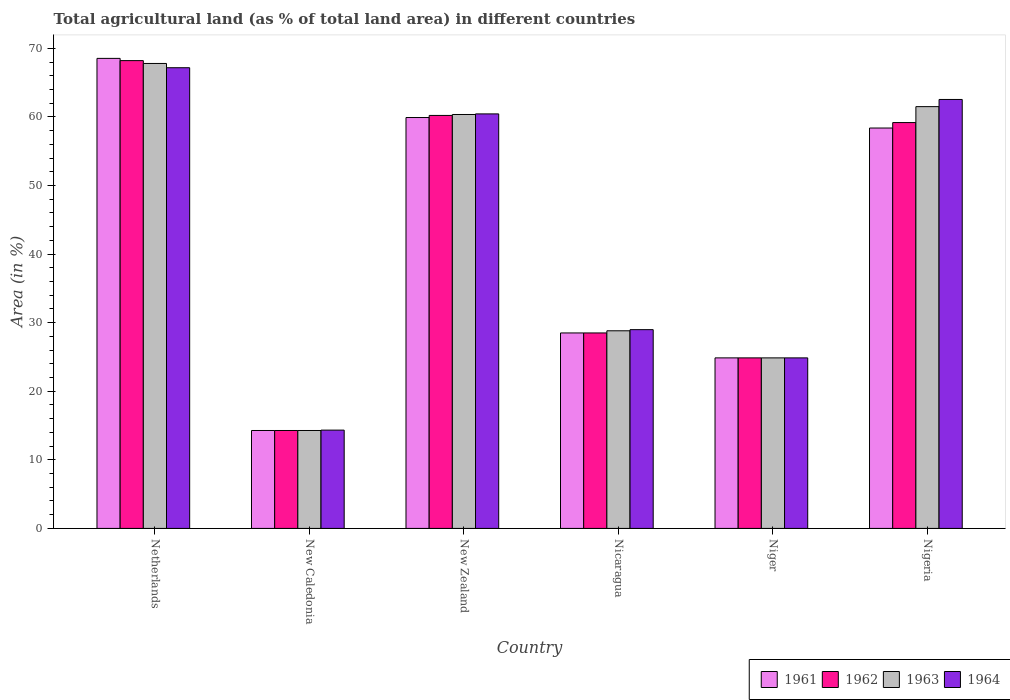How many groups of bars are there?
Ensure brevity in your answer.  6. How many bars are there on the 2nd tick from the left?
Your answer should be compact. 4. What is the label of the 2nd group of bars from the left?
Make the answer very short. New Caledonia. What is the percentage of agricultural land in 1963 in Nicaragua?
Give a very brief answer. 28.82. Across all countries, what is the maximum percentage of agricultural land in 1963?
Offer a very short reply. 67.8. Across all countries, what is the minimum percentage of agricultural land in 1962?
Keep it short and to the point. 14.28. In which country was the percentage of agricultural land in 1963 minimum?
Provide a succinct answer. New Caledonia. What is the total percentage of agricultural land in 1964 in the graph?
Offer a terse response. 258.36. What is the difference between the percentage of agricultural land in 1964 in Niger and that in Nigeria?
Your response must be concise. -37.68. What is the difference between the percentage of agricultural land in 1963 in Nigeria and the percentage of agricultural land in 1962 in Nicaragua?
Give a very brief answer. 33. What is the average percentage of agricultural land in 1961 per country?
Your answer should be compact. 42.42. What is the difference between the percentage of agricultural land of/in 1962 and percentage of agricultural land of/in 1963 in Nicaragua?
Offer a terse response. -0.32. What is the ratio of the percentage of agricultural land in 1961 in Nicaragua to that in Niger?
Offer a terse response. 1.15. Is the difference between the percentage of agricultural land in 1962 in New Zealand and Nigeria greater than the difference between the percentage of agricultural land in 1963 in New Zealand and Nigeria?
Provide a short and direct response. Yes. What is the difference between the highest and the second highest percentage of agricultural land in 1964?
Make the answer very short. 6.73. What is the difference between the highest and the lowest percentage of agricultural land in 1961?
Your answer should be compact. 54.26. In how many countries, is the percentage of agricultural land in 1961 greater than the average percentage of agricultural land in 1961 taken over all countries?
Your answer should be compact. 3. Is the sum of the percentage of agricultural land in 1963 in New Zealand and Niger greater than the maximum percentage of agricultural land in 1964 across all countries?
Ensure brevity in your answer.  Yes. What does the 4th bar from the left in Nigeria represents?
Make the answer very short. 1964. What does the 1st bar from the right in Niger represents?
Your answer should be compact. 1964. Is it the case that in every country, the sum of the percentage of agricultural land in 1962 and percentage of agricultural land in 1963 is greater than the percentage of agricultural land in 1961?
Your response must be concise. Yes. Are all the bars in the graph horizontal?
Give a very brief answer. No. How many countries are there in the graph?
Keep it short and to the point. 6. What is the difference between two consecutive major ticks on the Y-axis?
Ensure brevity in your answer.  10. Are the values on the major ticks of Y-axis written in scientific E-notation?
Offer a terse response. No. Does the graph contain any zero values?
Offer a terse response. No. Does the graph contain grids?
Offer a very short reply. No. Where does the legend appear in the graph?
Your response must be concise. Bottom right. How many legend labels are there?
Your answer should be very brief. 4. What is the title of the graph?
Your answer should be compact. Total agricultural land (as % of total land area) in different countries. What is the label or title of the X-axis?
Your answer should be very brief. Country. What is the label or title of the Y-axis?
Give a very brief answer. Area (in %). What is the Area (in %) of 1961 in Netherlands?
Your answer should be compact. 68.54. What is the Area (in %) of 1962 in Netherlands?
Make the answer very short. 68.22. What is the Area (in %) of 1963 in Netherlands?
Your response must be concise. 67.8. What is the Area (in %) in 1964 in Netherlands?
Keep it short and to the point. 67.18. What is the Area (in %) in 1961 in New Caledonia?
Offer a very short reply. 14.28. What is the Area (in %) of 1962 in New Caledonia?
Give a very brief answer. 14.28. What is the Area (in %) of 1963 in New Caledonia?
Provide a short and direct response. 14.28. What is the Area (in %) of 1964 in New Caledonia?
Keep it short and to the point. 14.33. What is the Area (in %) in 1961 in New Zealand?
Your answer should be very brief. 59.92. What is the Area (in %) of 1962 in New Zealand?
Provide a succinct answer. 60.22. What is the Area (in %) in 1963 in New Zealand?
Give a very brief answer. 60.36. What is the Area (in %) of 1964 in New Zealand?
Your answer should be compact. 60.45. What is the Area (in %) in 1961 in Nicaragua?
Offer a terse response. 28.5. What is the Area (in %) in 1962 in Nicaragua?
Give a very brief answer. 28.5. What is the Area (in %) in 1963 in Nicaragua?
Your answer should be very brief. 28.82. What is the Area (in %) in 1964 in Nicaragua?
Provide a succinct answer. 28.98. What is the Area (in %) in 1961 in Niger?
Keep it short and to the point. 24.87. What is the Area (in %) of 1962 in Niger?
Your answer should be compact. 24.87. What is the Area (in %) of 1963 in Niger?
Provide a succinct answer. 24.87. What is the Area (in %) in 1964 in Niger?
Give a very brief answer. 24.87. What is the Area (in %) of 1961 in Nigeria?
Ensure brevity in your answer.  58.39. What is the Area (in %) in 1962 in Nigeria?
Your response must be concise. 59.18. What is the Area (in %) of 1963 in Nigeria?
Offer a terse response. 61.51. What is the Area (in %) in 1964 in Nigeria?
Keep it short and to the point. 62.55. Across all countries, what is the maximum Area (in %) in 1961?
Your answer should be very brief. 68.54. Across all countries, what is the maximum Area (in %) of 1962?
Make the answer very short. 68.22. Across all countries, what is the maximum Area (in %) in 1963?
Your answer should be very brief. 67.8. Across all countries, what is the maximum Area (in %) in 1964?
Give a very brief answer. 67.18. Across all countries, what is the minimum Area (in %) in 1961?
Provide a succinct answer. 14.28. Across all countries, what is the minimum Area (in %) in 1962?
Give a very brief answer. 14.28. Across all countries, what is the minimum Area (in %) in 1963?
Offer a very short reply. 14.28. Across all countries, what is the minimum Area (in %) in 1964?
Offer a terse response. 14.33. What is the total Area (in %) in 1961 in the graph?
Offer a very short reply. 254.5. What is the total Area (in %) of 1962 in the graph?
Provide a short and direct response. 255.27. What is the total Area (in %) of 1963 in the graph?
Provide a short and direct response. 257.63. What is the total Area (in %) in 1964 in the graph?
Give a very brief answer. 258.36. What is the difference between the Area (in %) of 1961 in Netherlands and that in New Caledonia?
Your response must be concise. 54.26. What is the difference between the Area (in %) of 1962 in Netherlands and that in New Caledonia?
Your answer should be very brief. 53.94. What is the difference between the Area (in %) in 1963 in Netherlands and that in New Caledonia?
Keep it short and to the point. 53.52. What is the difference between the Area (in %) of 1964 in Netherlands and that in New Caledonia?
Your response must be concise. 52.85. What is the difference between the Area (in %) in 1961 in Netherlands and that in New Zealand?
Provide a short and direct response. 8.62. What is the difference between the Area (in %) in 1962 in Netherlands and that in New Zealand?
Offer a very short reply. 8. What is the difference between the Area (in %) in 1963 in Netherlands and that in New Zealand?
Your response must be concise. 7.44. What is the difference between the Area (in %) of 1964 in Netherlands and that in New Zealand?
Offer a terse response. 6.73. What is the difference between the Area (in %) in 1961 in Netherlands and that in Nicaragua?
Offer a very short reply. 40.04. What is the difference between the Area (in %) in 1962 in Netherlands and that in Nicaragua?
Make the answer very short. 39.71. What is the difference between the Area (in %) of 1963 in Netherlands and that in Nicaragua?
Your response must be concise. 38.98. What is the difference between the Area (in %) of 1964 in Netherlands and that in Nicaragua?
Offer a terse response. 38.2. What is the difference between the Area (in %) of 1961 in Netherlands and that in Niger?
Make the answer very short. 43.67. What is the difference between the Area (in %) of 1962 in Netherlands and that in Niger?
Your answer should be very brief. 43.35. What is the difference between the Area (in %) of 1963 in Netherlands and that in Niger?
Offer a very short reply. 42.93. What is the difference between the Area (in %) in 1964 in Netherlands and that in Niger?
Provide a succinct answer. 42.31. What is the difference between the Area (in %) in 1961 in Netherlands and that in Nigeria?
Keep it short and to the point. 10.16. What is the difference between the Area (in %) in 1962 in Netherlands and that in Nigeria?
Provide a succinct answer. 9.04. What is the difference between the Area (in %) of 1963 in Netherlands and that in Nigeria?
Make the answer very short. 6.3. What is the difference between the Area (in %) in 1964 in Netherlands and that in Nigeria?
Keep it short and to the point. 4.63. What is the difference between the Area (in %) in 1961 in New Caledonia and that in New Zealand?
Your response must be concise. -45.64. What is the difference between the Area (in %) in 1962 in New Caledonia and that in New Zealand?
Provide a succinct answer. -45.94. What is the difference between the Area (in %) of 1963 in New Caledonia and that in New Zealand?
Keep it short and to the point. -46.08. What is the difference between the Area (in %) of 1964 in New Caledonia and that in New Zealand?
Your answer should be compact. -46.11. What is the difference between the Area (in %) of 1961 in New Caledonia and that in Nicaragua?
Make the answer very short. -14.22. What is the difference between the Area (in %) in 1962 in New Caledonia and that in Nicaragua?
Provide a succinct answer. -14.22. What is the difference between the Area (in %) in 1963 in New Caledonia and that in Nicaragua?
Keep it short and to the point. -14.54. What is the difference between the Area (in %) of 1964 in New Caledonia and that in Nicaragua?
Provide a succinct answer. -14.65. What is the difference between the Area (in %) in 1961 in New Caledonia and that in Niger?
Your response must be concise. -10.59. What is the difference between the Area (in %) of 1962 in New Caledonia and that in Niger?
Offer a terse response. -10.59. What is the difference between the Area (in %) in 1963 in New Caledonia and that in Niger?
Your answer should be very brief. -10.59. What is the difference between the Area (in %) of 1964 in New Caledonia and that in Niger?
Keep it short and to the point. -10.54. What is the difference between the Area (in %) in 1961 in New Caledonia and that in Nigeria?
Offer a terse response. -44.11. What is the difference between the Area (in %) in 1962 in New Caledonia and that in Nigeria?
Your answer should be compact. -44.9. What is the difference between the Area (in %) in 1963 in New Caledonia and that in Nigeria?
Give a very brief answer. -47.23. What is the difference between the Area (in %) of 1964 in New Caledonia and that in Nigeria?
Offer a terse response. -48.22. What is the difference between the Area (in %) in 1961 in New Zealand and that in Nicaragua?
Give a very brief answer. 31.42. What is the difference between the Area (in %) in 1962 in New Zealand and that in Nicaragua?
Offer a very short reply. 31.72. What is the difference between the Area (in %) of 1963 in New Zealand and that in Nicaragua?
Ensure brevity in your answer.  31.54. What is the difference between the Area (in %) in 1964 in New Zealand and that in Nicaragua?
Your response must be concise. 31.46. What is the difference between the Area (in %) in 1961 in New Zealand and that in Niger?
Offer a terse response. 35.05. What is the difference between the Area (in %) of 1962 in New Zealand and that in Niger?
Offer a terse response. 35.35. What is the difference between the Area (in %) in 1963 in New Zealand and that in Niger?
Offer a very short reply. 35.49. What is the difference between the Area (in %) of 1964 in New Zealand and that in Niger?
Your answer should be compact. 35.58. What is the difference between the Area (in %) of 1961 in New Zealand and that in Nigeria?
Ensure brevity in your answer.  1.53. What is the difference between the Area (in %) in 1962 in New Zealand and that in Nigeria?
Your answer should be very brief. 1.04. What is the difference between the Area (in %) of 1963 in New Zealand and that in Nigeria?
Provide a succinct answer. -1.15. What is the difference between the Area (in %) of 1964 in New Zealand and that in Nigeria?
Provide a short and direct response. -2.11. What is the difference between the Area (in %) in 1961 in Nicaragua and that in Niger?
Provide a succinct answer. 3.63. What is the difference between the Area (in %) in 1962 in Nicaragua and that in Niger?
Provide a succinct answer. 3.63. What is the difference between the Area (in %) in 1963 in Nicaragua and that in Niger?
Your answer should be compact. 3.95. What is the difference between the Area (in %) in 1964 in Nicaragua and that in Niger?
Your answer should be very brief. 4.12. What is the difference between the Area (in %) of 1961 in Nicaragua and that in Nigeria?
Keep it short and to the point. -29.88. What is the difference between the Area (in %) in 1962 in Nicaragua and that in Nigeria?
Your response must be concise. -30.68. What is the difference between the Area (in %) of 1963 in Nicaragua and that in Nigeria?
Your answer should be compact. -32.69. What is the difference between the Area (in %) of 1964 in Nicaragua and that in Nigeria?
Offer a terse response. -33.57. What is the difference between the Area (in %) of 1961 in Niger and that in Nigeria?
Your answer should be very brief. -33.52. What is the difference between the Area (in %) of 1962 in Niger and that in Nigeria?
Give a very brief answer. -34.31. What is the difference between the Area (in %) in 1963 in Niger and that in Nigeria?
Provide a succinct answer. -36.64. What is the difference between the Area (in %) of 1964 in Niger and that in Nigeria?
Make the answer very short. -37.68. What is the difference between the Area (in %) of 1961 in Netherlands and the Area (in %) of 1962 in New Caledonia?
Offer a terse response. 54.26. What is the difference between the Area (in %) in 1961 in Netherlands and the Area (in %) in 1963 in New Caledonia?
Ensure brevity in your answer.  54.26. What is the difference between the Area (in %) of 1961 in Netherlands and the Area (in %) of 1964 in New Caledonia?
Your response must be concise. 54.21. What is the difference between the Area (in %) in 1962 in Netherlands and the Area (in %) in 1963 in New Caledonia?
Offer a terse response. 53.94. What is the difference between the Area (in %) of 1962 in Netherlands and the Area (in %) of 1964 in New Caledonia?
Make the answer very short. 53.88. What is the difference between the Area (in %) of 1963 in Netherlands and the Area (in %) of 1964 in New Caledonia?
Offer a terse response. 53.47. What is the difference between the Area (in %) in 1961 in Netherlands and the Area (in %) in 1962 in New Zealand?
Provide a succinct answer. 8.32. What is the difference between the Area (in %) of 1961 in Netherlands and the Area (in %) of 1963 in New Zealand?
Offer a terse response. 8.18. What is the difference between the Area (in %) in 1961 in Netherlands and the Area (in %) in 1964 in New Zealand?
Provide a short and direct response. 8.1. What is the difference between the Area (in %) in 1962 in Netherlands and the Area (in %) in 1963 in New Zealand?
Make the answer very short. 7.86. What is the difference between the Area (in %) of 1962 in Netherlands and the Area (in %) of 1964 in New Zealand?
Offer a very short reply. 7.77. What is the difference between the Area (in %) of 1963 in Netherlands and the Area (in %) of 1964 in New Zealand?
Your answer should be very brief. 7.36. What is the difference between the Area (in %) in 1961 in Netherlands and the Area (in %) in 1962 in Nicaragua?
Provide a short and direct response. 40.04. What is the difference between the Area (in %) of 1961 in Netherlands and the Area (in %) of 1963 in Nicaragua?
Offer a terse response. 39.72. What is the difference between the Area (in %) in 1961 in Netherlands and the Area (in %) in 1964 in Nicaragua?
Provide a succinct answer. 39.56. What is the difference between the Area (in %) in 1962 in Netherlands and the Area (in %) in 1963 in Nicaragua?
Your answer should be very brief. 39.4. What is the difference between the Area (in %) in 1962 in Netherlands and the Area (in %) in 1964 in Nicaragua?
Keep it short and to the point. 39.23. What is the difference between the Area (in %) in 1963 in Netherlands and the Area (in %) in 1964 in Nicaragua?
Provide a succinct answer. 38.82. What is the difference between the Area (in %) of 1961 in Netherlands and the Area (in %) of 1962 in Niger?
Give a very brief answer. 43.67. What is the difference between the Area (in %) in 1961 in Netherlands and the Area (in %) in 1963 in Niger?
Give a very brief answer. 43.67. What is the difference between the Area (in %) in 1961 in Netherlands and the Area (in %) in 1964 in Niger?
Keep it short and to the point. 43.67. What is the difference between the Area (in %) in 1962 in Netherlands and the Area (in %) in 1963 in Niger?
Provide a succinct answer. 43.35. What is the difference between the Area (in %) of 1962 in Netherlands and the Area (in %) of 1964 in Niger?
Provide a succinct answer. 43.35. What is the difference between the Area (in %) in 1963 in Netherlands and the Area (in %) in 1964 in Niger?
Your answer should be compact. 42.93. What is the difference between the Area (in %) in 1961 in Netherlands and the Area (in %) in 1962 in Nigeria?
Offer a terse response. 9.36. What is the difference between the Area (in %) of 1961 in Netherlands and the Area (in %) of 1963 in Nigeria?
Offer a very short reply. 7.04. What is the difference between the Area (in %) in 1961 in Netherlands and the Area (in %) in 1964 in Nigeria?
Your answer should be very brief. 5.99. What is the difference between the Area (in %) of 1962 in Netherlands and the Area (in %) of 1963 in Nigeria?
Offer a terse response. 6.71. What is the difference between the Area (in %) of 1962 in Netherlands and the Area (in %) of 1964 in Nigeria?
Offer a terse response. 5.66. What is the difference between the Area (in %) in 1963 in Netherlands and the Area (in %) in 1964 in Nigeria?
Provide a short and direct response. 5.25. What is the difference between the Area (in %) in 1961 in New Caledonia and the Area (in %) in 1962 in New Zealand?
Keep it short and to the point. -45.94. What is the difference between the Area (in %) of 1961 in New Caledonia and the Area (in %) of 1963 in New Zealand?
Your answer should be very brief. -46.08. What is the difference between the Area (in %) in 1961 in New Caledonia and the Area (in %) in 1964 in New Zealand?
Offer a very short reply. -46.17. What is the difference between the Area (in %) in 1962 in New Caledonia and the Area (in %) in 1963 in New Zealand?
Provide a succinct answer. -46.08. What is the difference between the Area (in %) in 1962 in New Caledonia and the Area (in %) in 1964 in New Zealand?
Make the answer very short. -46.17. What is the difference between the Area (in %) in 1963 in New Caledonia and the Area (in %) in 1964 in New Zealand?
Ensure brevity in your answer.  -46.17. What is the difference between the Area (in %) of 1961 in New Caledonia and the Area (in %) of 1962 in Nicaragua?
Keep it short and to the point. -14.22. What is the difference between the Area (in %) in 1961 in New Caledonia and the Area (in %) in 1963 in Nicaragua?
Give a very brief answer. -14.54. What is the difference between the Area (in %) in 1961 in New Caledonia and the Area (in %) in 1964 in Nicaragua?
Ensure brevity in your answer.  -14.71. What is the difference between the Area (in %) of 1962 in New Caledonia and the Area (in %) of 1963 in Nicaragua?
Your response must be concise. -14.54. What is the difference between the Area (in %) in 1962 in New Caledonia and the Area (in %) in 1964 in Nicaragua?
Your answer should be compact. -14.71. What is the difference between the Area (in %) of 1963 in New Caledonia and the Area (in %) of 1964 in Nicaragua?
Your answer should be compact. -14.71. What is the difference between the Area (in %) in 1961 in New Caledonia and the Area (in %) in 1962 in Niger?
Ensure brevity in your answer.  -10.59. What is the difference between the Area (in %) in 1961 in New Caledonia and the Area (in %) in 1963 in Niger?
Your answer should be very brief. -10.59. What is the difference between the Area (in %) in 1961 in New Caledonia and the Area (in %) in 1964 in Niger?
Make the answer very short. -10.59. What is the difference between the Area (in %) in 1962 in New Caledonia and the Area (in %) in 1963 in Niger?
Your response must be concise. -10.59. What is the difference between the Area (in %) in 1962 in New Caledonia and the Area (in %) in 1964 in Niger?
Provide a short and direct response. -10.59. What is the difference between the Area (in %) of 1963 in New Caledonia and the Area (in %) of 1964 in Niger?
Offer a terse response. -10.59. What is the difference between the Area (in %) in 1961 in New Caledonia and the Area (in %) in 1962 in Nigeria?
Give a very brief answer. -44.9. What is the difference between the Area (in %) of 1961 in New Caledonia and the Area (in %) of 1963 in Nigeria?
Offer a very short reply. -47.23. What is the difference between the Area (in %) in 1961 in New Caledonia and the Area (in %) in 1964 in Nigeria?
Give a very brief answer. -48.27. What is the difference between the Area (in %) in 1962 in New Caledonia and the Area (in %) in 1963 in Nigeria?
Offer a very short reply. -47.23. What is the difference between the Area (in %) in 1962 in New Caledonia and the Area (in %) in 1964 in Nigeria?
Keep it short and to the point. -48.27. What is the difference between the Area (in %) in 1963 in New Caledonia and the Area (in %) in 1964 in Nigeria?
Your response must be concise. -48.27. What is the difference between the Area (in %) in 1961 in New Zealand and the Area (in %) in 1962 in Nicaragua?
Keep it short and to the point. 31.42. What is the difference between the Area (in %) of 1961 in New Zealand and the Area (in %) of 1963 in Nicaragua?
Provide a short and direct response. 31.1. What is the difference between the Area (in %) in 1961 in New Zealand and the Area (in %) in 1964 in Nicaragua?
Give a very brief answer. 30.93. What is the difference between the Area (in %) in 1962 in New Zealand and the Area (in %) in 1963 in Nicaragua?
Your answer should be very brief. 31.4. What is the difference between the Area (in %) in 1962 in New Zealand and the Area (in %) in 1964 in Nicaragua?
Give a very brief answer. 31.24. What is the difference between the Area (in %) in 1963 in New Zealand and the Area (in %) in 1964 in Nicaragua?
Provide a short and direct response. 31.37. What is the difference between the Area (in %) of 1961 in New Zealand and the Area (in %) of 1962 in Niger?
Give a very brief answer. 35.05. What is the difference between the Area (in %) in 1961 in New Zealand and the Area (in %) in 1963 in Niger?
Provide a succinct answer. 35.05. What is the difference between the Area (in %) of 1961 in New Zealand and the Area (in %) of 1964 in Niger?
Ensure brevity in your answer.  35.05. What is the difference between the Area (in %) of 1962 in New Zealand and the Area (in %) of 1963 in Niger?
Give a very brief answer. 35.35. What is the difference between the Area (in %) of 1962 in New Zealand and the Area (in %) of 1964 in Niger?
Your answer should be compact. 35.35. What is the difference between the Area (in %) of 1963 in New Zealand and the Area (in %) of 1964 in Niger?
Give a very brief answer. 35.49. What is the difference between the Area (in %) of 1961 in New Zealand and the Area (in %) of 1962 in Nigeria?
Make the answer very short. 0.74. What is the difference between the Area (in %) of 1961 in New Zealand and the Area (in %) of 1963 in Nigeria?
Offer a terse response. -1.59. What is the difference between the Area (in %) of 1961 in New Zealand and the Area (in %) of 1964 in Nigeria?
Make the answer very short. -2.63. What is the difference between the Area (in %) of 1962 in New Zealand and the Area (in %) of 1963 in Nigeria?
Give a very brief answer. -1.28. What is the difference between the Area (in %) of 1962 in New Zealand and the Area (in %) of 1964 in Nigeria?
Offer a terse response. -2.33. What is the difference between the Area (in %) of 1963 in New Zealand and the Area (in %) of 1964 in Nigeria?
Offer a terse response. -2.19. What is the difference between the Area (in %) in 1961 in Nicaragua and the Area (in %) in 1962 in Niger?
Offer a very short reply. 3.63. What is the difference between the Area (in %) in 1961 in Nicaragua and the Area (in %) in 1963 in Niger?
Make the answer very short. 3.63. What is the difference between the Area (in %) in 1961 in Nicaragua and the Area (in %) in 1964 in Niger?
Your response must be concise. 3.63. What is the difference between the Area (in %) of 1962 in Nicaragua and the Area (in %) of 1963 in Niger?
Ensure brevity in your answer.  3.63. What is the difference between the Area (in %) in 1962 in Nicaragua and the Area (in %) in 1964 in Niger?
Your response must be concise. 3.63. What is the difference between the Area (in %) in 1963 in Nicaragua and the Area (in %) in 1964 in Niger?
Provide a succinct answer. 3.95. What is the difference between the Area (in %) in 1961 in Nicaragua and the Area (in %) in 1962 in Nigeria?
Make the answer very short. -30.68. What is the difference between the Area (in %) of 1961 in Nicaragua and the Area (in %) of 1963 in Nigeria?
Ensure brevity in your answer.  -33. What is the difference between the Area (in %) in 1961 in Nicaragua and the Area (in %) in 1964 in Nigeria?
Your answer should be compact. -34.05. What is the difference between the Area (in %) in 1962 in Nicaragua and the Area (in %) in 1963 in Nigeria?
Give a very brief answer. -33. What is the difference between the Area (in %) of 1962 in Nicaragua and the Area (in %) of 1964 in Nigeria?
Your answer should be very brief. -34.05. What is the difference between the Area (in %) in 1963 in Nicaragua and the Area (in %) in 1964 in Nigeria?
Provide a succinct answer. -33.73. What is the difference between the Area (in %) of 1961 in Niger and the Area (in %) of 1962 in Nigeria?
Offer a terse response. -34.31. What is the difference between the Area (in %) of 1961 in Niger and the Area (in %) of 1963 in Nigeria?
Your response must be concise. -36.64. What is the difference between the Area (in %) of 1961 in Niger and the Area (in %) of 1964 in Nigeria?
Your answer should be very brief. -37.68. What is the difference between the Area (in %) in 1962 in Niger and the Area (in %) in 1963 in Nigeria?
Make the answer very short. -36.64. What is the difference between the Area (in %) of 1962 in Niger and the Area (in %) of 1964 in Nigeria?
Offer a very short reply. -37.68. What is the difference between the Area (in %) in 1963 in Niger and the Area (in %) in 1964 in Nigeria?
Offer a terse response. -37.68. What is the average Area (in %) of 1961 per country?
Your answer should be very brief. 42.42. What is the average Area (in %) in 1962 per country?
Your response must be concise. 42.54. What is the average Area (in %) of 1963 per country?
Offer a very short reply. 42.94. What is the average Area (in %) in 1964 per country?
Make the answer very short. 43.06. What is the difference between the Area (in %) in 1961 and Area (in %) in 1962 in Netherlands?
Make the answer very short. 0.33. What is the difference between the Area (in %) in 1961 and Area (in %) in 1963 in Netherlands?
Offer a terse response. 0.74. What is the difference between the Area (in %) in 1961 and Area (in %) in 1964 in Netherlands?
Provide a succinct answer. 1.36. What is the difference between the Area (in %) in 1962 and Area (in %) in 1963 in Netherlands?
Offer a terse response. 0.41. What is the difference between the Area (in %) of 1962 and Area (in %) of 1964 in Netherlands?
Give a very brief answer. 1.04. What is the difference between the Area (in %) in 1963 and Area (in %) in 1964 in Netherlands?
Offer a very short reply. 0.62. What is the difference between the Area (in %) in 1961 and Area (in %) in 1963 in New Caledonia?
Offer a very short reply. 0. What is the difference between the Area (in %) of 1961 and Area (in %) of 1964 in New Caledonia?
Keep it short and to the point. -0.05. What is the difference between the Area (in %) in 1962 and Area (in %) in 1964 in New Caledonia?
Provide a succinct answer. -0.05. What is the difference between the Area (in %) in 1963 and Area (in %) in 1964 in New Caledonia?
Offer a very short reply. -0.05. What is the difference between the Area (in %) in 1961 and Area (in %) in 1962 in New Zealand?
Keep it short and to the point. -0.3. What is the difference between the Area (in %) in 1961 and Area (in %) in 1963 in New Zealand?
Ensure brevity in your answer.  -0.44. What is the difference between the Area (in %) of 1961 and Area (in %) of 1964 in New Zealand?
Offer a terse response. -0.53. What is the difference between the Area (in %) of 1962 and Area (in %) of 1963 in New Zealand?
Give a very brief answer. -0.14. What is the difference between the Area (in %) in 1962 and Area (in %) in 1964 in New Zealand?
Your answer should be very brief. -0.22. What is the difference between the Area (in %) in 1963 and Area (in %) in 1964 in New Zealand?
Keep it short and to the point. -0.09. What is the difference between the Area (in %) of 1961 and Area (in %) of 1963 in Nicaragua?
Your answer should be compact. -0.32. What is the difference between the Area (in %) in 1961 and Area (in %) in 1964 in Nicaragua?
Ensure brevity in your answer.  -0.48. What is the difference between the Area (in %) in 1962 and Area (in %) in 1963 in Nicaragua?
Make the answer very short. -0.32. What is the difference between the Area (in %) of 1962 and Area (in %) of 1964 in Nicaragua?
Your answer should be very brief. -0.48. What is the difference between the Area (in %) in 1963 and Area (in %) in 1964 in Nicaragua?
Offer a very short reply. -0.17. What is the difference between the Area (in %) of 1961 and Area (in %) of 1962 in Niger?
Offer a very short reply. 0. What is the difference between the Area (in %) in 1961 and Area (in %) in 1963 in Niger?
Provide a short and direct response. 0. What is the difference between the Area (in %) in 1961 and Area (in %) in 1964 in Niger?
Your answer should be very brief. 0. What is the difference between the Area (in %) of 1962 and Area (in %) of 1964 in Niger?
Your answer should be compact. 0. What is the difference between the Area (in %) in 1963 and Area (in %) in 1964 in Niger?
Your response must be concise. 0. What is the difference between the Area (in %) in 1961 and Area (in %) in 1962 in Nigeria?
Make the answer very short. -0.79. What is the difference between the Area (in %) of 1961 and Area (in %) of 1963 in Nigeria?
Offer a terse response. -3.12. What is the difference between the Area (in %) in 1961 and Area (in %) in 1964 in Nigeria?
Provide a short and direct response. -4.17. What is the difference between the Area (in %) in 1962 and Area (in %) in 1963 in Nigeria?
Ensure brevity in your answer.  -2.32. What is the difference between the Area (in %) of 1962 and Area (in %) of 1964 in Nigeria?
Offer a terse response. -3.37. What is the difference between the Area (in %) of 1963 and Area (in %) of 1964 in Nigeria?
Offer a terse response. -1.05. What is the ratio of the Area (in %) in 1961 in Netherlands to that in New Caledonia?
Offer a terse response. 4.8. What is the ratio of the Area (in %) of 1962 in Netherlands to that in New Caledonia?
Provide a short and direct response. 4.78. What is the ratio of the Area (in %) in 1963 in Netherlands to that in New Caledonia?
Your answer should be compact. 4.75. What is the ratio of the Area (in %) of 1964 in Netherlands to that in New Caledonia?
Provide a succinct answer. 4.69. What is the ratio of the Area (in %) in 1961 in Netherlands to that in New Zealand?
Your response must be concise. 1.14. What is the ratio of the Area (in %) in 1962 in Netherlands to that in New Zealand?
Keep it short and to the point. 1.13. What is the ratio of the Area (in %) of 1963 in Netherlands to that in New Zealand?
Offer a terse response. 1.12. What is the ratio of the Area (in %) of 1964 in Netherlands to that in New Zealand?
Give a very brief answer. 1.11. What is the ratio of the Area (in %) in 1961 in Netherlands to that in Nicaragua?
Your response must be concise. 2.4. What is the ratio of the Area (in %) in 1962 in Netherlands to that in Nicaragua?
Offer a very short reply. 2.39. What is the ratio of the Area (in %) of 1963 in Netherlands to that in Nicaragua?
Provide a succinct answer. 2.35. What is the ratio of the Area (in %) in 1964 in Netherlands to that in Nicaragua?
Make the answer very short. 2.32. What is the ratio of the Area (in %) in 1961 in Netherlands to that in Niger?
Provide a succinct answer. 2.76. What is the ratio of the Area (in %) of 1962 in Netherlands to that in Niger?
Your answer should be compact. 2.74. What is the ratio of the Area (in %) of 1963 in Netherlands to that in Niger?
Provide a succinct answer. 2.73. What is the ratio of the Area (in %) in 1964 in Netherlands to that in Niger?
Keep it short and to the point. 2.7. What is the ratio of the Area (in %) of 1961 in Netherlands to that in Nigeria?
Offer a very short reply. 1.17. What is the ratio of the Area (in %) in 1962 in Netherlands to that in Nigeria?
Keep it short and to the point. 1.15. What is the ratio of the Area (in %) of 1963 in Netherlands to that in Nigeria?
Your response must be concise. 1.1. What is the ratio of the Area (in %) in 1964 in Netherlands to that in Nigeria?
Your answer should be compact. 1.07. What is the ratio of the Area (in %) of 1961 in New Caledonia to that in New Zealand?
Offer a terse response. 0.24. What is the ratio of the Area (in %) of 1962 in New Caledonia to that in New Zealand?
Your answer should be very brief. 0.24. What is the ratio of the Area (in %) in 1963 in New Caledonia to that in New Zealand?
Your answer should be compact. 0.24. What is the ratio of the Area (in %) of 1964 in New Caledonia to that in New Zealand?
Keep it short and to the point. 0.24. What is the ratio of the Area (in %) in 1961 in New Caledonia to that in Nicaragua?
Provide a short and direct response. 0.5. What is the ratio of the Area (in %) of 1962 in New Caledonia to that in Nicaragua?
Offer a terse response. 0.5. What is the ratio of the Area (in %) of 1963 in New Caledonia to that in Nicaragua?
Provide a succinct answer. 0.5. What is the ratio of the Area (in %) of 1964 in New Caledonia to that in Nicaragua?
Offer a very short reply. 0.49. What is the ratio of the Area (in %) of 1961 in New Caledonia to that in Niger?
Your answer should be compact. 0.57. What is the ratio of the Area (in %) in 1962 in New Caledonia to that in Niger?
Ensure brevity in your answer.  0.57. What is the ratio of the Area (in %) of 1963 in New Caledonia to that in Niger?
Provide a short and direct response. 0.57. What is the ratio of the Area (in %) in 1964 in New Caledonia to that in Niger?
Your answer should be compact. 0.58. What is the ratio of the Area (in %) of 1961 in New Caledonia to that in Nigeria?
Give a very brief answer. 0.24. What is the ratio of the Area (in %) of 1962 in New Caledonia to that in Nigeria?
Offer a very short reply. 0.24. What is the ratio of the Area (in %) of 1963 in New Caledonia to that in Nigeria?
Give a very brief answer. 0.23. What is the ratio of the Area (in %) of 1964 in New Caledonia to that in Nigeria?
Offer a very short reply. 0.23. What is the ratio of the Area (in %) of 1961 in New Zealand to that in Nicaragua?
Offer a very short reply. 2.1. What is the ratio of the Area (in %) of 1962 in New Zealand to that in Nicaragua?
Your answer should be compact. 2.11. What is the ratio of the Area (in %) of 1963 in New Zealand to that in Nicaragua?
Provide a short and direct response. 2.09. What is the ratio of the Area (in %) of 1964 in New Zealand to that in Nicaragua?
Your answer should be very brief. 2.09. What is the ratio of the Area (in %) in 1961 in New Zealand to that in Niger?
Your answer should be compact. 2.41. What is the ratio of the Area (in %) of 1962 in New Zealand to that in Niger?
Offer a very short reply. 2.42. What is the ratio of the Area (in %) in 1963 in New Zealand to that in Niger?
Provide a short and direct response. 2.43. What is the ratio of the Area (in %) of 1964 in New Zealand to that in Niger?
Your answer should be compact. 2.43. What is the ratio of the Area (in %) in 1961 in New Zealand to that in Nigeria?
Make the answer very short. 1.03. What is the ratio of the Area (in %) of 1962 in New Zealand to that in Nigeria?
Give a very brief answer. 1.02. What is the ratio of the Area (in %) of 1963 in New Zealand to that in Nigeria?
Offer a very short reply. 0.98. What is the ratio of the Area (in %) of 1964 in New Zealand to that in Nigeria?
Provide a succinct answer. 0.97. What is the ratio of the Area (in %) in 1961 in Nicaragua to that in Niger?
Give a very brief answer. 1.15. What is the ratio of the Area (in %) in 1962 in Nicaragua to that in Niger?
Your response must be concise. 1.15. What is the ratio of the Area (in %) of 1963 in Nicaragua to that in Niger?
Provide a short and direct response. 1.16. What is the ratio of the Area (in %) in 1964 in Nicaragua to that in Niger?
Provide a short and direct response. 1.17. What is the ratio of the Area (in %) in 1961 in Nicaragua to that in Nigeria?
Provide a succinct answer. 0.49. What is the ratio of the Area (in %) of 1962 in Nicaragua to that in Nigeria?
Give a very brief answer. 0.48. What is the ratio of the Area (in %) of 1963 in Nicaragua to that in Nigeria?
Keep it short and to the point. 0.47. What is the ratio of the Area (in %) in 1964 in Nicaragua to that in Nigeria?
Your response must be concise. 0.46. What is the ratio of the Area (in %) in 1961 in Niger to that in Nigeria?
Offer a very short reply. 0.43. What is the ratio of the Area (in %) in 1962 in Niger to that in Nigeria?
Your response must be concise. 0.42. What is the ratio of the Area (in %) in 1963 in Niger to that in Nigeria?
Provide a short and direct response. 0.4. What is the ratio of the Area (in %) of 1964 in Niger to that in Nigeria?
Ensure brevity in your answer.  0.4. What is the difference between the highest and the second highest Area (in %) of 1961?
Your answer should be very brief. 8.62. What is the difference between the highest and the second highest Area (in %) in 1962?
Provide a short and direct response. 8. What is the difference between the highest and the second highest Area (in %) of 1963?
Your answer should be very brief. 6.3. What is the difference between the highest and the second highest Area (in %) in 1964?
Your answer should be very brief. 4.63. What is the difference between the highest and the lowest Area (in %) in 1961?
Keep it short and to the point. 54.26. What is the difference between the highest and the lowest Area (in %) of 1962?
Your answer should be very brief. 53.94. What is the difference between the highest and the lowest Area (in %) in 1963?
Provide a short and direct response. 53.52. What is the difference between the highest and the lowest Area (in %) of 1964?
Your answer should be very brief. 52.85. 